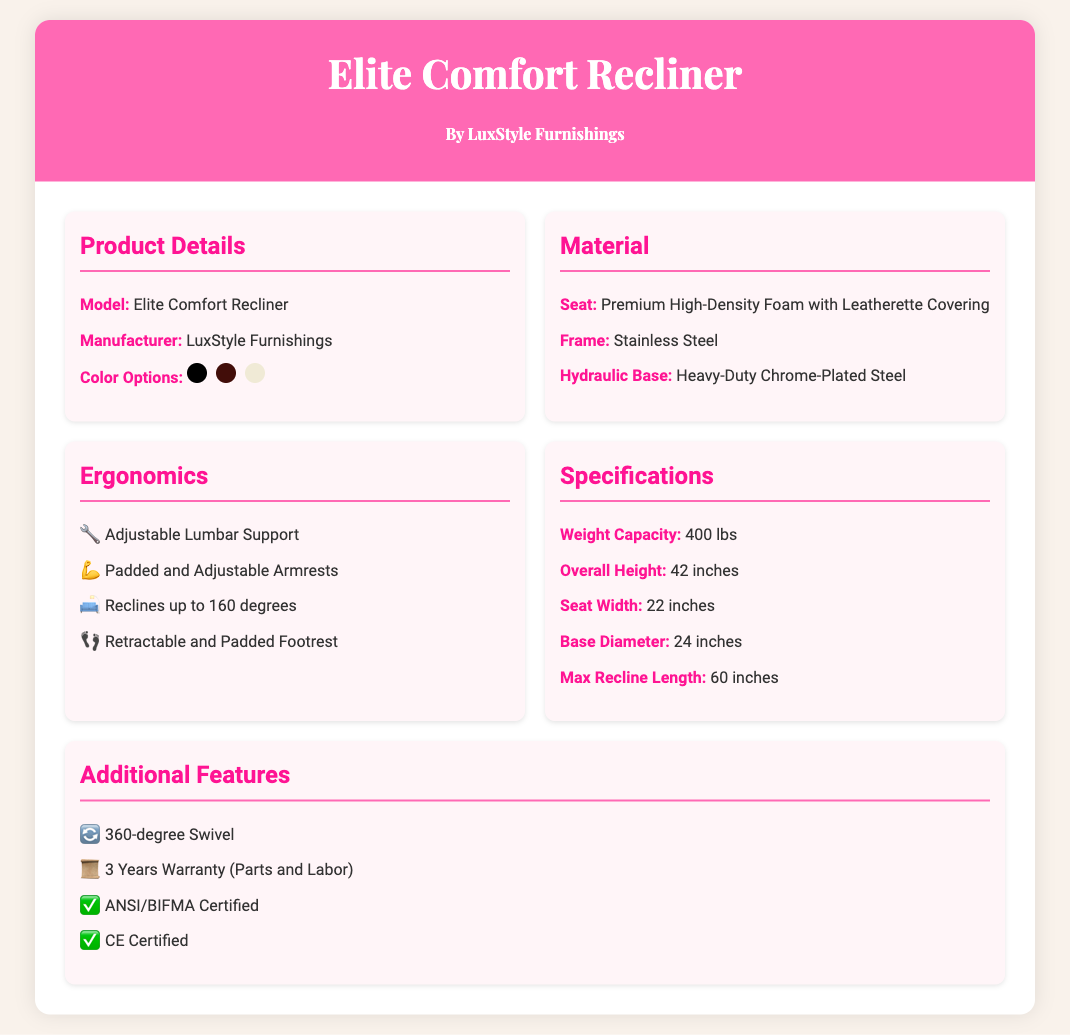what is the model of the chair? The model is stated at the beginning of the Product Details section.
Answer: Elite Comfort Recliner who is the manufacturer? The manufacturer is specified in the Product Details section.
Answer: LuxStyle Furnishings what material is used for the seat? The seat material is listed in the Material section of the document.
Answer: Premium High-Density Foam with Leatherette Covering how many degrees does the chair recline? The maximum recline angle is mentioned in the Ergonomics section.
Answer: 160 degrees what is the weight capacity of the chair? The weight capacity is found in the Specifications section.
Answer: 400 lbs how many color options are available? The number of color options can be counted in the Color Options section.
Answer: 3 which certification confirms parts and labor warranty? The warranty information appears in the Additional Features section.
Answer: 3 Years Warranty (Parts and Labor) what is the overall height of the chair? The overall height is listed in the Specifications section.
Answer: 42 inches does the chair have a swivel feature? The presence of a swivel feature is mentioned in the Additional Features section.
Answer: Yes 